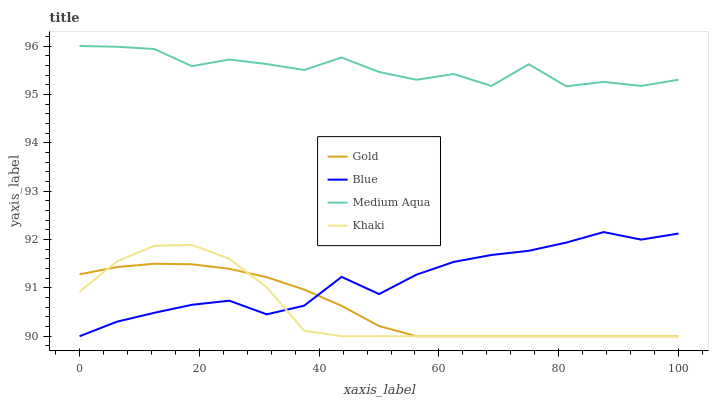Does Khaki have the minimum area under the curve?
Answer yes or no. Yes. Does Medium Aqua have the maximum area under the curve?
Answer yes or no. Yes. Does Medium Aqua have the minimum area under the curve?
Answer yes or no. No. Does Khaki have the maximum area under the curve?
Answer yes or no. No. Is Gold the smoothest?
Answer yes or no. Yes. Is Medium Aqua the roughest?
Answer yes or no. Yes. Is Khaki the smoothest?
Answer yes or no. No. Is Khaki the roughest?
Answer yes or no. No. Does Blue have the lowest value?
Answer yes or no. Yes. Does Medium Aqua have the lowest value?
Answer yes or no. No. Does Medium Aqua have the highest value?
Answer yes or no. Yes. Does Khaki have the highest value?
Answer yes or no. No. Is Gold less than Medium Aqua?
Answer yes or no. Yes. Is Medium Aqua greater than Gold?
Answer yes or no. Yes. Does Blue intersect Khaki?
Answer yes or no. Yes. Is Blue less than Khaki?
Answer yes or no. No. Is Blue greater than Khaki?
Answer yes or no. No. Does Gold intersect Medium Aqua?
Answer yes or no. No. 